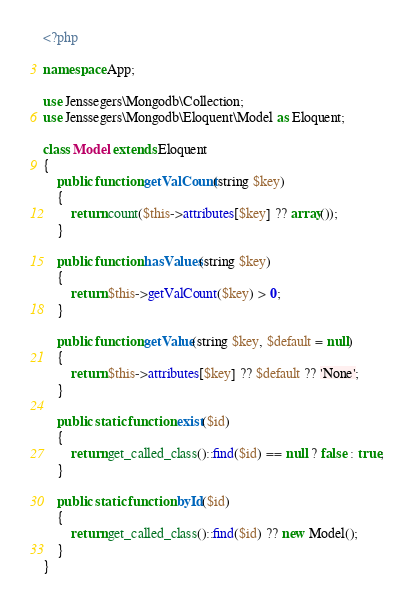Convert code to text. <code><loc_0><loc_0><loc_500><loc_500><_PHP_><?php

namespace App;

use Jenssegers\Mongodb\Collection;
use Jenssegers\Mongodb\Eloquent\Model as Eloquent;

class Model extends Eloquent
{
    public function getValCount(string $key)
    {
        return count($this->attributes[$key] ?? array());
    }

    public function hasValues(string $key)
    {
        return $this->getValCount($key) > 0;
    }

    public function getValue(string $key, $default = null)
    {
        return $this->attributes[$key] ?? $default ?? 'None';
    }

    public static function exist($id)
    {
        return get_called_class()::find($id) == null ? false : true;
    }

    public static function byId($id)
    {
        return get_called_class()::find($id) ?? new Model();
    }
}</code> 